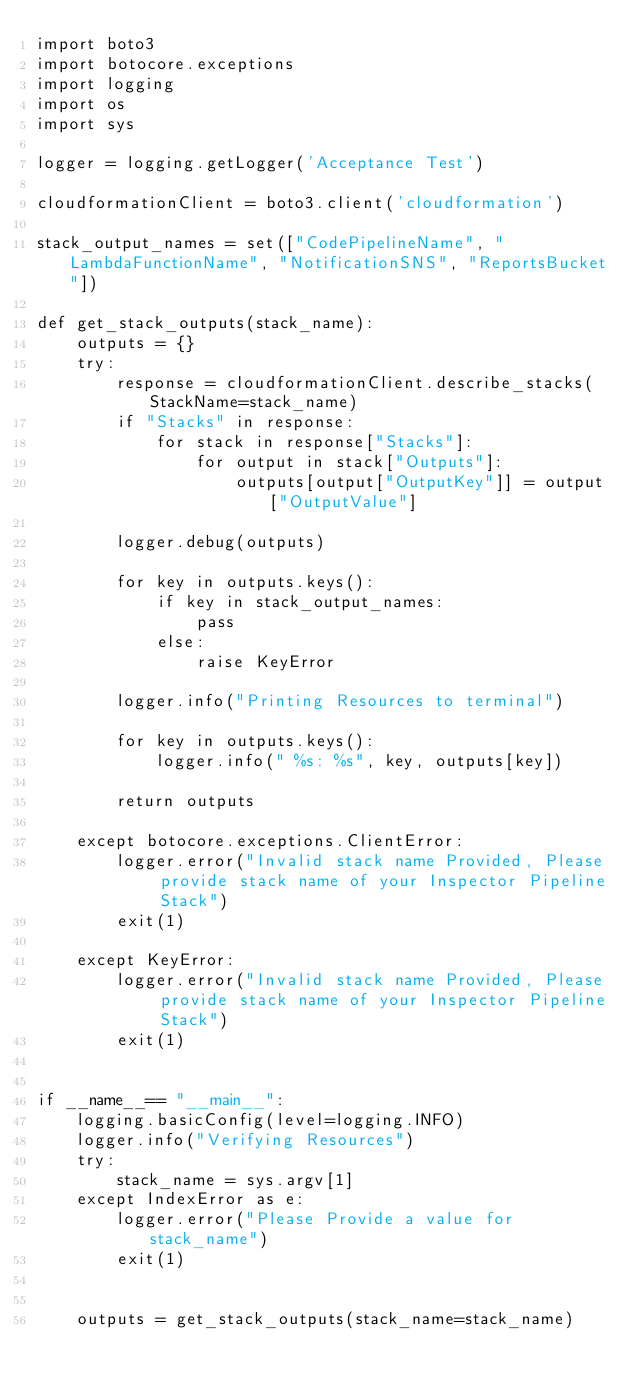Convert code to text. <code><loc_0><loc_0><loc_500><loc_500><_Python_>import boto3
import botocore.exceptions
import logging
import os
import sys

logger = logging.getLogger('Acceptance Test')

cloudformationClient = boto3.client('cloudformation')

stack_output_names = set(["CodePipelineName", "LambdaFunctionName", "NotificationSNS", "ReportsBucket"])

def get_stack_outputs(stack_name):
    outputs = {}
    try:
        response = cloudformationClient.describe_stacks(StackName=stack_name)
        if "Stacks" in response:
            for stack in response["Stacks"]:
                for output in stack["Outputs"]:
                    outputs[output["OutputKey"]] = output["OutputValue"]

        logger.debug(outputs)

        for key in outputs.keys():
            if key in stack_output_names:
                pass
            else:
                raise KeyError
        
        logger.info("Printing Resources to terminal")
        
        for key in outputs.keys():
            logger.info(" %s: %s", key, outputs[key])

        return outputs

    except botocore.exceptions.ClientError:
        logger.error("Invalid stack name Provided, Please provide stack name of your Inspector Pipeline Stack")
        exit(1)

    except KeyError:
        logger.error("Invalid stack name Provided, Please provide stack name of your Inspector Pipeline Stack")
        exit(1)


if __name__== "__main__":
    logging.basicConfig(level=logging.INFO)
    logger.info("Verifying Resources")
    try:
        stack_name = sys.argv[1]
    except IndexError as e:
        logger.error("Please Provide a value for stack_name")
        exit(1)
    
    
    outputs = get_stack_outputs(stack_name=stack_name)</code> 